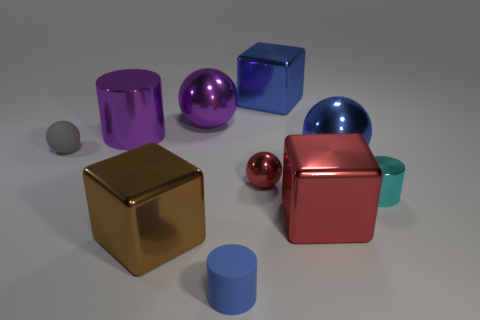There is a matte object that is behind the cylinder in front of the metallic cylinder in front of the gray object; how big is it?
Provide a short and direct response. Small. How many small red spheres have the same material as the small cyan cylinder?
Offer a terse response. 1. Is the number of tiny blue rubber objects less than the number of tiny cylinders?
Your response must be concise. Yes. There is a blue metal object that is the same shape as the big red object; what size is it?
Keep it short and to the point. Large. Are the big blue thing on the right side of the large blue shiny block and the blue cylinder made of the same material?
Offer a terse response. No. Do the blue rubber object and the tiny cyan shiny thing have the same shape?
Make the answer very short. Yes. What number of objects are either large spheres to the left of the big red block or small cyan metal cubes?
Provide a succinct answer. 1. What size is the cyan object that is made of the same material as the tiny red sphere?
Your answer should be very brief. Small. What number of balls are the same color as the small rubber cylinder?
Make the answer very short. 1. How many big things are either yellow matte things or blue matte cylinders?
Keep it short and to the point. 0. 